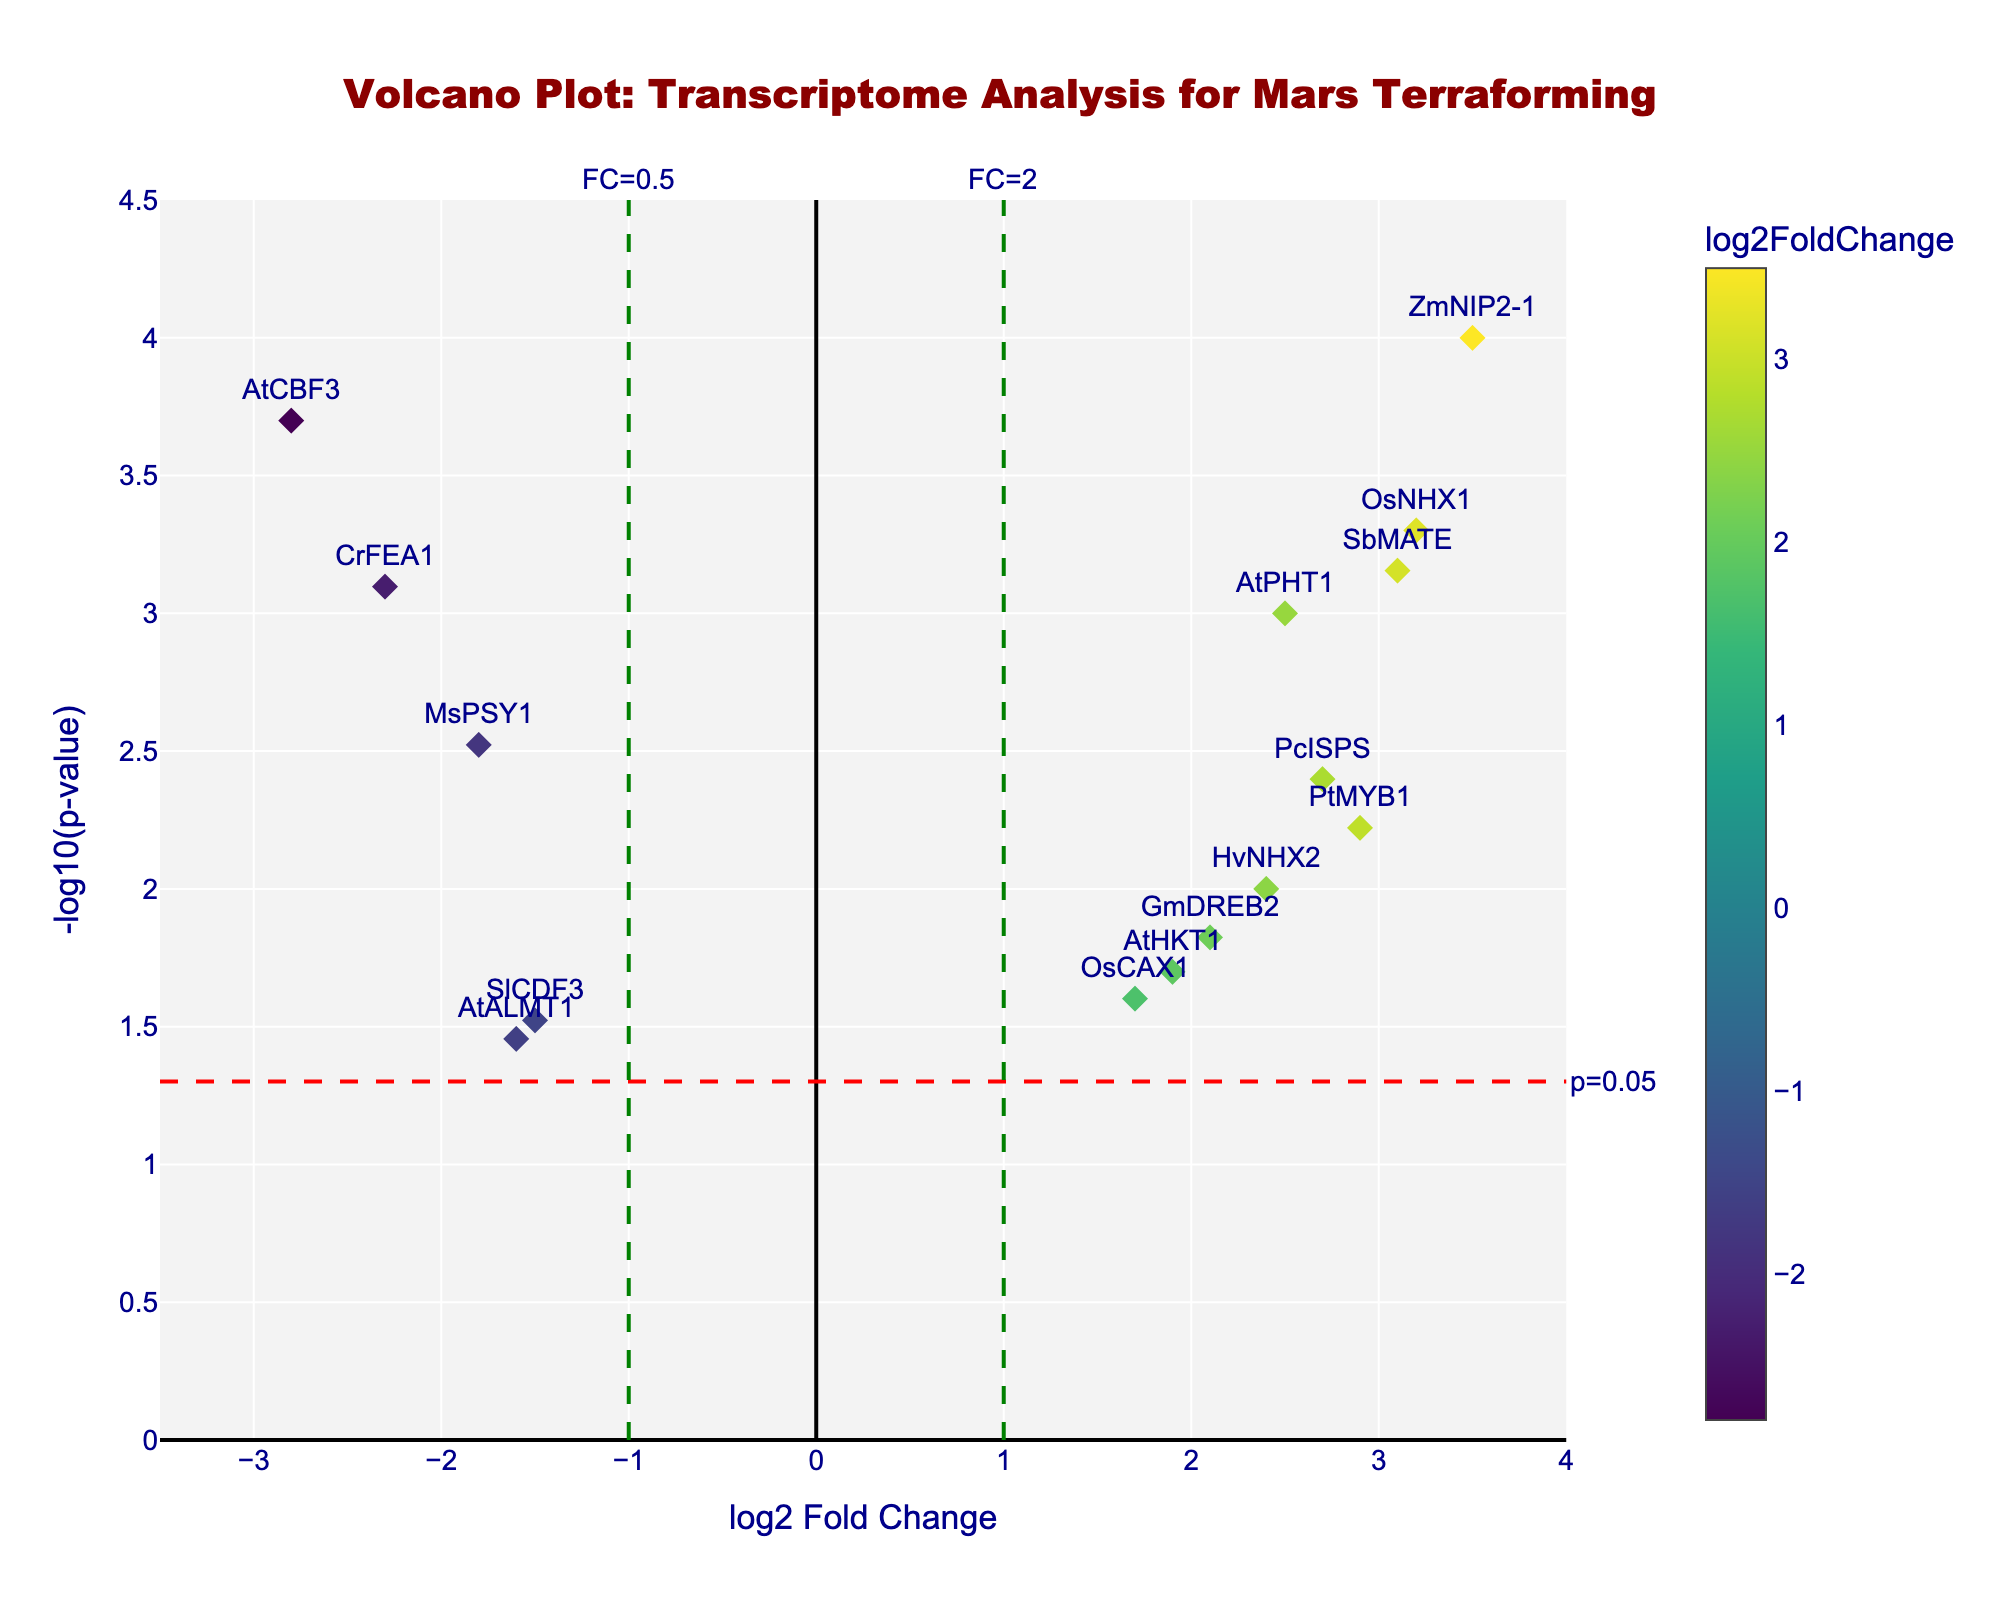What's the title of the figure? The title is written at the top of the plot and reads "Volcano Plot: Transcriptome Analysis for Mars Terraforming"
Answer: Volcano Plot: Transcriptome Analysis for Mars Terraforming What do the x and y axes represent? The x-axis represents "log2 Fold Change," which shows the fold change in gene expression on a log scale. The y-axis represents "-log10(p-value)," which shows the significance of the change in gene expression on a negative log scale
Answer: log2 Fold Change, -log10(p-value) Which gene has the highest -log10(p-value)? -log10(p-value) is highest for the gene that is furthest up the y-axis. In this figure, the gene ZmNIP2-1 has the highest -log10(p-value)
Answer: ZmNIP2-1 Among the genes with positive log2FoldChange, which one has the highest significance? We look at the genes with positive log2FoldChange (right of the y-axis) and then find the one that is highest up on the y-axis, which indicates the highest -log10(p-value). ZmNIP2-1 has the highest significance among them
Answer: ZmNIP2-1 Are there any genes with a log2FoldChange close to zero but a significant p-value? A log2FoldChange close to zero would be around the middle of the x-axis. However, looking at all significant genes (above the red threshold line), no gene with a log2FoldChange near zero is significant
Answer: No Which gene has the smallest log2FoldChange but is still significantly upregulated (log2FoldChange > 0)? To be significantly upregulated, the gene must be to the right of the x-axis with a large -log10(p-value). Look for the smallest positive log2FoldChange, which is AtHKT1 with a value of 1.9 and is above the threshold line
Answer: AtHKT1 How many genes have a fold change greater than 2 (log2FoldChange > 1) and a significant p-value? Examine the right side of the plot for points above the horizontal threshold line where log2FoldChange > 1. These genes are ZmNIP2-1, OsNHX1, PtMYB1, PcISPS, SbMATE, and HvNHX2 making it six genes
Answer: 6 Which gene shows the most extreme downregulation with a highly significant p-value? Downregulated genes have negative log2FoldChange. The most extreme downregulation will have the farthest to the left and the highest in terms of y-value. AtCBF3 with log2FoldChange of -2.8 and a significant p-value fits this
Answer: AtCBF3 